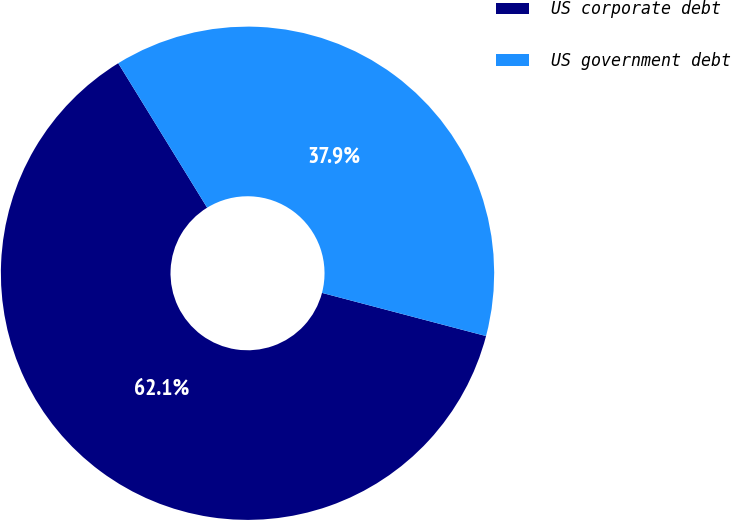Convert chart. <chart><loc_0><loc_0><loc_500><loc_500><pie_chart><fcel>US corporate debt<fcel>US government debt<nl><fcel>62.12%<fcel>37.88%<nl></chart> 